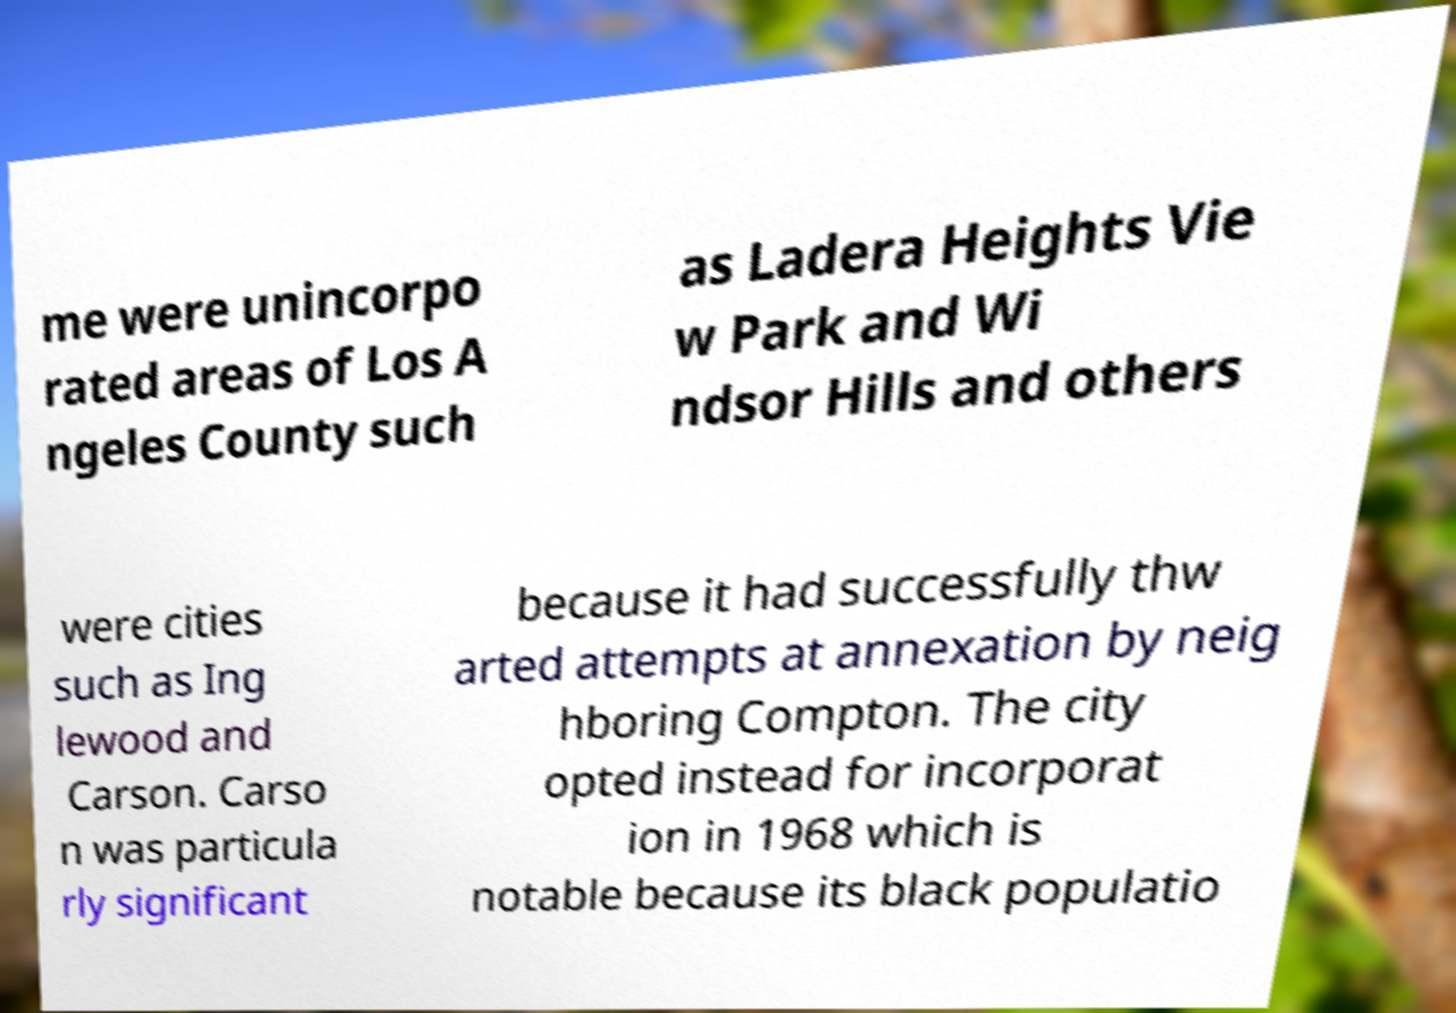Please identify and transcribe the text found in this image. me were unincorpo rated areas of Los A ngeles County such as Ladera Heights Vie w Park and Wi ndsor Hills and others were cities such as Ing lewood and Carson. Carso n was particula rly significant because it had successfully thw arted attempts at annexation by neig hboring Compton. The city opted instead for incorporat ion in 1968 which is notable because its black populatio 